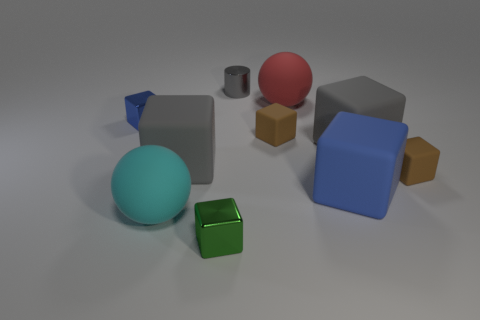There is a green block that is made of the same material as the small gray object; what size is it?
Provide a succinct answer. Small. How many red things are the same shape as the cyan rubber object?
Provide a short and direct response. 1. There is a red ball that is the same size as the cyan matte object; what is its material?
Provide a short and direct response. Rubber. Are there any gray cubes that have the same material as the big red ball?
Keep it short and to the point. Yes. There is a small cube that is both to the left of the small metal cylinder and behind the green metal block; what is its color?
Provide a succinct answer. Blue. What number of other things are there of the same color as the small cylinder?
Give a very brief answer. 2. There is a tiny object behind the small block that is left of the large ball that is in front of the red sphere; what is its material?
Offer a terse response. Metal. What number of cubes are either gray things or large gray objects?
Offer a very short reply. 2. There is a large block left of the small metallic thing that is behind the tiny blue shiny cube; how many small green shiny things are to the right of it?
Make the answer very short. 1. Does the cyan matte object have the same shape as the red object?
Provide a succinct answer. Yes. 